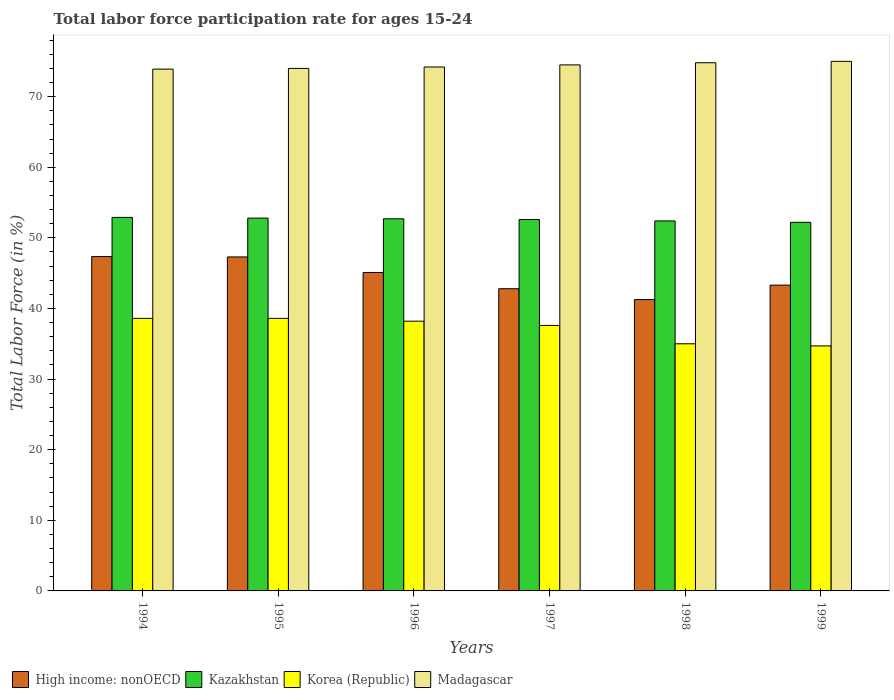How many different coloured bars are there?
Offer a very short reply. 4. How many bars are there on the 1st tick from the left?
Offer a very short reply. 4. How many bars are there on the 2nd tick from the right?
Offer a terse response. 4. What is the label of the 4th group of bars from the left?
Your answer should be compact. 1997. What is the labor force participation rate in Kazakhstan in 1996?
Ensure brevity in your answer.  52.7. Across all years, what is the maximum labor force participation rate in Kazakhstan?
Keep it short and to the point. 52.9. Across all years, what is the minimum labor force participation rate in Kazakhstan?
Your response must be concise. 52.2. In which year was the labor force participation rate in Kazakhstan maximum?
Give a very brief answer. 1994. In which year was the labor force participation rate in Korea (Republic) minimum?
Your response must be concise. 1999. What is the total labor force participation rate in Korea (Republic) in the graph?
Make the answer very short. 222.7. What is the difference between the labor force participation rate in Kazakhstan in 1995 and that in 1997?
Your answer should be compact. 0.2. What is the difference between the labor force participation rate in Korea (Republic) in 1999 and the labor force participation rate in Kazakhstan in 1995?
Ensure brevity in your answer.  -18.1. What is the average labor force participation rate in Korea (Republic) per year?
Offer a very short reply. 37.12. In the year 1999, what is the difference between the labor force participation rate in High income: nonOECD and labor force participation rate in Kazakhstan?
Give a very brief answer. -8.89. In how many years, is the labor force participation rate in Madagascar greater than 40 %?
Make the answer very short. 6. What is the ratio of the labor force participation rate in Madagascar in 1996 to that in 1997?
Your response must be concise. 1. Is the labor force participation rate in High income: nonOECD in 1994 less than that in 1996?
Your answer should be compact. No. Is the difference between the labor force participation rate in High income: nonOECD in 1996 and 1999 greater than the difference between the labor force participation rate in Kazakhstan in 1996 and 1999?
Your response must be concise. Yes. What is the difference between the highest and the second highest labor force participation rate in Madagascar?
Your answer should be very brief. 0.2. What is the difference between the highest and the lowest labor force participation rate in High income: nonOECD?
Keep it short and to the point. 6.09. In how many years, is the labor force participation rate in High income: nonOECD greater than the average labor force participation rate in High income: nonOECD taken over all years?
Make the answer very short. 3. Is the sum of the labor force participation rate in Korea (Republic) in 1995 and 1996 greater than the maximum labor force participation rate in High income: nonOECD across all years?
Provide a succinct answer. Yes. Is it the case that in every year, the sum of the labor force participation rate in High income: nonOECD and labor force participation rate in Madagascar is greater than the sum of labor force participation rate in Kazakhstan and labor force participation rate in Korea (Republic)?
Provide a succinct answer. Yes. What does the 2nd bar from the left in 1998 represents?
Provide a short and direct response. Kazakhstan. What does the 1st bar from the right in 1999 represents?
Keep it short and to the point. Madagascar. Are all the bars in the graph horizontal?
Make the answer very short. No. How many years are there in the graph?
Your response must be concise. 6. What is the difference between two consecutive major ticks on the Y-axis?
Ensure brevity in your answer.  10. Does the graph contain any zero values?
Make the answer very short. No. How many legend labels are there?
Provide a succinct answer. 4. How are the legend labels stacked?
Offer a terse response. Horizontal. What is the title of the graph?
Offer a terse response. Total labor force participation rate for ages 15-24. Does "South Asia" appear as one of the legend labels in the graph?
Your response must be concise. No. What is the Total Labor Force (in %) in High income: nonOECD in 1994?
Keep it short and to the point. 47.35. What is the Total Labor Force (in %) of Kazakhstan in 1994?
Keep it short and to the point. 52.9. What is the Total Labor Force (in %) in Korea (Republic) in 1994?
Your answer should be compact. 38.6. What is the Total Labor Force (in %) in Madagascar in 1994?
Ensure brevity in your answer.  73.9. What is the Total Labor Force (in %) of High income: nonOECD in 1995?
Your answer should be very brief. 47.3. What is the Total Labor Force (in %) in Kazakhstan in 1995?
Your answer should be very brief. 52.8. What is the Total Labor Force (in %) in Korea (Republic) in 1995?
Ensure brevity in your answer.  38.6. What is the Total Labor Force (in %) in High income: nonOECD in 1996?
Your answer should be compact. 45.1. What is the Total Labor Force (in %) of Kazakhstan in 1996?
Give a very brief answer. 52.7. What is the Total Labor Force (in %) of Korea (Republic) in 1996?
Offer a terse response. 38.2. What is the Total Labor Force (in %) in Madagascar in 1996?
Ensure brevity in your answer.  74.2. What is the Total Labor Force (in %) of High income: nonOECD in 1997?
Your answer should be compact. 42.8. What is the Total Labor Force (in %) of Kazakhstan in 1997?
Offer a very short reply. 52.6. What is the Total Labor Force (in %) in Korea (Republic) in 1997?
Make the answer very short. 37.6. What is the Total Labor Force (in %) of Madagascar in 1997?
Keep it short and to the point. 74.5. What is the Total Labor Force (in %) of High income: nonOECD in 1998?
Keep it short and to the point. 41.26. What is the Total Labor Force (in %) of Kazakhstan in 1998?
Give a very brief answer. 52.4. What is the Total Labor Force (in %) in Madagascar in 1998?
Your answer should be very brief. 74.8. What is the Total Labor Force (in %) in High income: nonOECD in 1999?
Your answer should be compact. 43.31. What is the Total Labor Force (in %) in Kazakhstan in 1999?
Give a very brief answer. 52.2. What is the Total Labor Force (in %) in Korea (Republic) in 1999?
Keep it short and to the point. 34.7. Across all years, what is the maximum Total Labor Force (in %) in High income: nonOECD?
Provide a succinct answer. 47.35. Across all years, what is the maximum Total Labor Force (in %) of Kazakhstan?
Your answer should be compact. 52.9. Across all years, what is the maximum Total Labor Force (in %) of Korea (Republic)?
Ensure brevity in your answer.  38.6. Across all years, what is the maximum Total Labor Force (in %) in Madagascar?
Offer a terse response. 75. Across all years, what is the minimum Total Labor Force (in %) of High income: nonOECD?
Provide a succinct answer. 41.26. Across all years, what is the minimum Total Labor Force (in %) in Kazakhstan?
Offer a terse response. 52.2. Across all years, what is the minimum Total Labor Force (in %) of Korea (Republic)?
Your answer should be compact. 34.7. Across all years, what is the minimum Total Labor Force (in %) in Madagascar?
Offer a very short reply. 73.9. What is the total Total Labor Force (in %) of High income: nonOECD in the graph?
Your response must be concise. 267.12. What is the total Total Labor Force (in %) in Kazakhstan in the graph?
Your answer should be very brief. 315.6. What is the total Total Labor Force (in %) of Korea (Republic) in the graph?
Offer a terse response. 222.7. What is the total Total Labor Force (in %) in Madagascar in the graph?
Keep it short and to the point. 446.4. What is the difference between the Total Labor Force (in %) of High income: nonOECD in 1994 and that in 1995?
Offer a very short reply. 0.05. What is the difference between the Total Labor Force (in %) in Korea (Republic) in 1994 and that in 1995?
Provide a succinct answer. 0. What is the difference between the Total Labor Force (in %) of High income: nonOECD in 1994 and that in 1996?
Your answer should be compact. 2.25. What is the difference between the Total Labor Force (in %) of Kazakhstan in 1994 and that in 1996?
Provide a succinct answer. 0.2. What is the difference between the Total Labor Force (in %) of High income: nonOECD in 1994 and that in 1997?
Make the answer very short. 4.55. What is the difference between the Total Labor Force (in %) in Kazakhstan in 1994 and that in 1997?
Offer a very short reply. 0.3. What is the difference between the Total Labor Force (in %) in Korea (Republic) in 1994 and that in 1997?
Provide a short and direct response. 1. What is the difference between the Total Labor Force (in %) of Madagascar in 1994 and that in 1997?
Provide a succinct answer. -0.6. What is the difference between the Total Labor Force (in %) of High income: nonOECD in 1994 and that in 1998?
Make the answer very short. 6.09. What is the difference between the Total Labor Force (in %) in Madagascar in 1994 and that in 1998?
Give a very brief answer. -0.9. What is the difference between the Total Labor Force (in %) of High income: nonOECD in 1994 and that in 1999?
Your response must be concise. 4.04. What is the difference between the Total Labor Force (in %) of Korea (Republic) in 1994 and that in 1999?
Your response must be concise. 3.9. What is the difference between the Total Labor Force (in %) of High income: nonOECD in 1995 and that in 1996?
Provide a short and direct response. 2.2. What is the difference between the Total Labor Force (in %) of Kazakhstan in 1995 and that in 1996?
Offer a terse response. 0.1. What is the difference between the Total Labor Force (in %) in Korea (Republic) in 1995 and that in 1996?
Make the answer very short. 0.4. What is the difference between the Total Labor Force (in %) of Madagascar in 1995 and that in 1996?
Provide a short and direct response. -0.2. What is the difference between the Total Labor Force (in %) of High income: nonOECD in 1995 and that in 1997?
Your answer should be compact. 4.5. What is the difference between the Total Labor Force (in %) of Korea (Republic) in 1995 and that in 1997?
Provide a succinct answer. 1. What is the difference between the Total Labor Force (in %) in Madagascar in 1995 and that in 1997?
Your answer should be compact. -0.5. What is the difference between the Total Labor Force (in %) of High income: nonOECD in 1995 and that in 1998?
Your answer should be very brief. 6.04. What is the difference between the Total Labor Force (in %) in Kazakhstan in 1995 and that in 1998?
Keep it short and to the point. 0.4. What is the difference between the Total Labor Force (in %) in Korea (Republic) in 1995 and that in 1998?
Ensure brevity in your answer.  3.6. What is the difference between the Total Labor Force (in %) in Madagascar in 1995 and that in 1998?
Provide a succinct answer. -0.8. What is the difference between the Total Labor Force (in %) of High income: nonOECD in 1995 and that in 1999?
Make the answer very short. 3.99. What is the difference between the Total Labor Force (in %) in Kazakhstan in 1995 and that in 1999?
Offer a terse response. 0.6. What is the difference between the Total Labor Force (in %) of High income: nonOECD in 1996 and that in 1997?
Offer a very short reply. 2.3. What is the difference between the Total Labor Force (in %) in Madagascar in 1996 and that in 1997?
Give a very brief answer. -0.3. What is the difference between the Total Labor Force (in %) in High income: nonOECD in 1996 and that in 1998?
Provide a short and direct response. 3.84. What is the difference between the Total Labor Force (in %) of Korea (Republic) in 1996 and that in 1998?
Ensure brevity in your answer.  3.2. What is the difference between the Total Labor Force (in %) of High income: nonOECD in 1996 and that in 1999?
Keep it short and to the point. 1.79. What is the difference between the Total Labor Force (in %) in Kazakhstan in 1996 and that in 1999?
Your response must be concise. 0.5. What is the difference between the Total Labor Force (in %) of Korea (Republic) in 1996 and that in 1999?
Offer a very short reply. 3.5. What is the difference between the Total Labor Force (in %) in Madagascar in 1996 and that in 1999?
Your answer should be compact. -0.8. What is the difference between the Total Labor Force (in %) of High income: nonOECD in 1997 and that in 1998?
Your answer should be compact. 1.54. What is the difference between the Total Labor Force (in %) of Kazakhstan in 1997 and that in 1998?
Provide a succinct answer. 0.2. What is the difference between the Total Labor Force (in %) of Madagascar in 1997 and that in 1998?
Ensure brevity in your answer.  -0.3. What is the difference between the Total Labor Force (in %) in High income: nonOECD in 1997 and that in 1999?
Offer a terse response. -0.51. What is the difference between the Total Labor Force (in %) of Kazakhstan in 1997 and that in 1999?
Give a very brief answer. 0.4. What is the difference between the Total Labor Force (in %) in Madagascar in 1997 and that in 1999?
Offer a very short reply. -0.5. What is the difference between the Total Labor Force (in %) of High income: nonOECD in 1998 and that in 1999?
Keep it short and to the point. -2.05. What is the difference between the Total Labor Force (in %) in Madagascar in 1998 and that in 1999?
Give a very brief answer. -0.2. What is the difference between the Total Labor Force (in %) in High income: nonOECD in 1994 and the Total Labor Force (in %) in Kazakhstan in 1995?
Your answer should be compact. -5.45. What is the difference between the Total Labor Force (in %) in High income: nonOECD in 1994 and the Total Labor Force (in %) in Korea (Republic) in 1995?
Provide a short and direct response. 8.75. What is the difference between the Total Labor Force (in %) of High income: nonOECD in 1994 and the Total Labor Force (in %) of Madagascar in 1995?
Your response must be concise. -26.65. What is the difference between the Total Labor Force (in %) in Kazakhstan in 1994 and the Total Labor Force (in %) in Korea (Republic) in 1995?
Your response must be concise. 14.3. What is the difference between the Total Labor Force (in %) in Kazakhstan in 1994 and the Total Labor Force (in %) in Madagascar in 1995?
Give a very brief answer. -21.1. What is the difference between the Total Labor Force (in %) in Korea (Republic) in 1994 and the Total Labor Force (in %) in Madagascar in 1995?
Offer a very short reply. -35.4. What is the difference between the Total Labor Force (in %) in High income: nonOECD in 1994 and the Total Labor Force (in %) in Kazakhstan in 1996?
Your response must be concise. -5.35. What is the difference between the Total Labor Force (in %) in High income: nonOECD in 1994 and the Total Labor Force (in %) in Korea (Republic) in 1996?
Provide a succinct answer. 9.15. What is the difference between the Total Labor Force (in %) in High income: nonOECD in 1994 and the Total Labor Force (in %) in Madagascar in 1996?
Offer a very short reply. -26.85. What is the difference between the Total Labor Force (in %) in Kazakhstan in 1994 and the Total Labor Force (in %) in Madagascar in 1996?
Your response must be concise. -21.3. What is the difference between the Total Labor Force (in %) of Korea (Republic) in 1994 and the Total Labor Force (in %) of Madagascar in 1996?
Provide a succinct answer. -35.6. What is the difference between the Total Labor Force (in %) of High income: nonOECD in 1994 and the Total Labor Force (in %) of Kazakhstan in 1997?
Keep it short and to the point. -5.25. What is the difference between the Total Labor Force (in %) in High income: nonOECD in 1994 and the Total Labor Force (in %) in Korea (Republic) in 1997?
Keep it short and to the point. 9.75. What is the difference between the Total Labor Force (in %) in High income: nonOECD in 1994 and the Total Labor Force (in %) in Madagascar in 1997?
Your answer should be compact. -27.15. What is the difference between the Total Labor Force (in %) of Kazakhstan in 1994 and the Total Labor Force (in %) of Madagascar in 1997?
Offer a very short reply. -21.6. What is the difference between the Total Labor Force (in %) in Korea (Republic) in 1994 and the Total Labor Force (in %) in Madagascar in 1997?
Your answer should be compact. -35.9. What is the difference between the Total Labor Force (in %) in High income: nonOECD in 1994 and the Total Labor Force (in %) in Kazakhstan in 1998?
Your answer should be very brief. -5.05. What is the difference between the Total Labor Force (in %) of High income: nonOECD in 1994 and the Total Labor Force (in %) of Korea (Republic) in 1998?
Provide a succinct answer. 12.35. What is the difference between the Total Labor Force (in %) of High income: nonOECD in 1994 and the Total Labor Force (in %) of Madagascar in 1998?
Keep it short and to the point. -27.45. What is the difference between the Total Labor Force (in %) in Kazakhstan in 1994 and the Total Labor Force (in %) in Madagascar in 1998?
Provide a short and direct response. -21.9. What is the difference between the Total Labor Force (in %) of Korea (Republic) in 1994 and the Total Labor Force (in %) of Madagascar in 1998?
Your answer should be compact. -36.2. What is the difference between the Total Labor Force (in %) of High income: nonOECD in 1994 and the Total Labor Force (in %) of Kazakhstan in 1999?
Provide a short and direct response. -4.85. What is the difference between the Total Labor Force (in %) in High income: nonOECD in 1994 and the Total Labor Force (in %) in Korea (Republic) in 1999?
Offer a terse response. 12.65. What is the difference between the Total Labor Force (in %) in High income: nonOECD in 1994 and the Total Labor Force (in %) in Madagascar in 1999?
Ensure brevity in your answer.  -27.65. What is the difference between the Total Labor Force (in %) of Kazakhstan in 1994 and the Total Labor Force (in %) of Madagascar in 1999?
Give a very brief answer. -22.1. What is the difference between the Total Labor Force (in %) in Korea (Republic) in 1994 and the Total Labor Force (in %) in Madagascar in 1999?
Offer a very short reply. -36.4. What is the difference between the Total Labor Force (in %) in High income: nonOECD in 1995 and the Total Labor Force (in %) in Kazakhstan in 1996?
Make the answer very short. -5.4. What is the difference between the Total Labor Force (in %) in High income: nonOECD in 1995 and the Total Labor Force (in %) in Korea (Republic) in 1996?
Your answer should be very brief. 9.1. What is the difference between the Total Labor Force (in %) in High income: nonOECD in 1995 and the Total Labor Force (in %) in Madagascar in 1996?
Make the answer very short. -26.9. What is the difference between the Total Labor Force (in %) of Kazakhstan in 1995 and the Total Labor Force (in %) of Madagascar in 1996?
Your answer should be compact. -21.4. What is the difference between the Total Labor Force (in %) in Korea (Republic) in 1995 and the Total Labor Force (in %) in Madagascar in 1996?
Your answer should be compact. -35.6. What is the difference between the Total Labor Force (in %) of High income: nonOECD in 1995 and the Total Labor Force (in %) of Kazakhstan in 1997?
Keep it short and to the point. -5.3. What is the difference between the Total Labor Force (in %) in High income: nonOECD in 1995 and the Total Labor Force (in %) in Korea (Republic) in 1997?
Keep it short and to the point. 9.7. What is the difference between the Total Labor Force (in %) of High income: nonOECD in 1995 and the Total Labor Force (in %) of Madagascar in 1997?
Make the answer very short. -27.2. What is the difference between the Total Labor Force (in %) of Kazakhstan in 1995 and the Total Labor Force (in %) of Korea (Republic) in 1997?
Your response must be concise. 15.2. What is the difference between the Total Labor Force (in %) of Kazakhstan in 1995 and the Total Labor Force (in %) of Madagascar in 1997?
Your response must be concise. -21.7. What is the difference between the Total Labor Force (in %) in Korea (Republic) in 1995 and the Total Labor Force (in %) in Madagascar in 1997?
Make the answer very short. -35.9. What is the difference between the Total Labor Force (in %) of High income: nonOECD in 1995 and the Total Labor Force (in %) of Kazakhstan in 1998?
Your response must be concise. -5.1. What is the difference between the Total Labor Force (in %) of High income: nonOECD in 1995 and the Total Labor Force (in %) of Korea (Republic) in 1998?
Your answer should be compact. 12.3. What is the difference between the Total Labor Force (in %) in High income: nonOECD in 1995 and the Total Labor Force (in %) in Madagascar in 1998?
Provide a succinct answer. -27.5. What is the difference between the Total Labor Force (in %) in Kazakhstan in 1995 and the Total Labor Force (in %) in Madagascar in 1998?
Make the answer very short. -22. What is the difference between the Total Labor Force (in %) in Korea (Republic) in 1995 and the Total Labor Force (in %) in Madagascar in 1998?
Your answer should be very brief. -36.2. What is the difference between the Total Labor Force (in %) in High income: nonOECD in 1995 and the Total Labor Force (in %) in Kazakhstan in 1999?
Give a very brief answer. -4.9. What is the difference between the Total Labor Force (in %) of High income: nonOECD in 1995 and the Total Labor Force (in %) of Korea (Republic) in 1999?
Offer a terse response. 12.6. What is the difference between the Total Labor Force (in %) in High income: nonOECD in 1995 and the Total Labor Force (in %) in Madagascar in 1999?
Ensure brevity in your answer.  -27.7. What is the difference between the Total Labor Force (in %) in Kazakhstan in 1995 and the Total Labor Force (in %) in Madagascar in 1999?
Your answer should be very brief. -22.2. What is the difference between the Total Labor Force (in %) in Korea (Republic) in 1995 and the Total Labor Force (in %) in Madagascar in 1999?
Ensure brevity in your answer.  -36.4. What is the difference between the Total Labor Force (in %) in High income: nonOECD in 1996 and the Total Labor Force (in %) in Kazakhstan in 1997?
Provide a succinct answer. -7.5. What is the difference between the Total Labor Force (in %) in High income: nonOECD in 1996 and the Total Labor Force (in %) in Korea (Republic) in 1997?
Your answer should be compact. 7.5. What is the difference between the Total Labor Force (in %) of High income: nonOECD in 1996 and the Total Labor Force (in %) of Madagascar in 1997?
Your response must be concise. -29.4. What is the difference between the Total Labor Force (in %) in Kazakhstan in 1996 and the Total Labor Force (in %) in Madagascar in 1997?
Provide a succinct answer. -21.8. What is the difference between the Total Labor Force (in %) in Korea (Republic) in 1996 and the Total Labor Force (in %) in Madagascar in 1997?
Offer a very short reply. -36.3. What is the difference between the Total Labor Force (in %) in High income: nonOECD in 1996 and the Total Labor Force (in %) in Kazakhstan in 1998?
Your answer should be compact. -7.3. What is the difference between the Total Labor Force (in %) of High income: nonOECD in 1996 and the Total Labor Force (in %) of Korea (Republic) in 1998?
Your answer should be very brief. 10.1. What is the difference between the Total Labor Force (in %) in High income: nonOECD in 1996 and the Total Labor Force (in %) in Madagascar in 1998?
Your answer should be very brief. -29.7. What is the difference between the Total Labor Force (in %) in Kazakhstan in 1996 and the Total Labor Force (in %) in Madagascar in 1998?
Give a very brief answer. -22.1. What is the difference between the Total Labor Force (in %) of Korea (Republic) in 1996 and the Total Labor Force (in %) of Madagascar in 1998?
Give a very brief answer. -36.6. What is the difference between the Total Labor Force (in %) of High income: nonOECD in 1996 and the Total Labor Force (in %) of Kazakhstan in 1999?
Provide a succinct answer. -7.1. What is the difference between the Total Labor Force (in %) in High income: nonOECD in 1996 and the Total Labor Force (in %) in Korea (Republic) in 1999?
Offer a very short reply. 10.4. What is the difference between the Total Labor Force (in %) of High income: nonOECD in 1996 and the Total Labor Force (in %) of Madagascar in 1999?
Provide a short and direct response. -29.9. What is the difference between the Total Labor Force (in %) of Kazakhstan in 1996 and the Total Labor Force (in %) of Korea (Republic) in 1999?
Give a very brief answer. 18. What is the difference between the Total Labor Force (in %) in Kazakhstan in 1996 and the Total Labor Force (in %) in Madagascar in 1999?
Provide a succinct answer. -22.3. What is the difference between the Total Labor Force (in %) of Korea (Republic) in 1996 and the Total Labor Force (in %) of Madagascar in 1999?
Your answer should be very brief. -36.8. What is the difference between the Total Labor Force (in %) in High income: nonOECD in 1997 and the Total Labor Force (in %) in Kazakhstan in 1998?
Offer a terse response. -9.6. What is the difference between the Total Labor Force (in %) of High income: nonOECD in 1997 and the Total Labor Force (in %) of Korea (Republic) in 1998?
Provide a short and direct response. 7.8. What is the difference between the Total Labor Force (in %) of High income: nonOECD in 1997 and the Total Labor Force (in %) of Madagascar in 1998?
Your answer should be compact. -32. What is the difference between the Total Labor Force (in %) in Kazakhstan in 1997 and the Total Labor Force (in %) in Madagascar in 1998?
Offer a very short reply. -22.2. What is the difference between the Total Labor Force (in %) in Korea (Republic) in 1997 and the Total Labor Force (in %) in Madagascar in 1998?
Your answer should be compact. -37.2. What is the difference between the Total Labor Force (in %) in High income: nonOECD in 1997 and the Total Labor Force (in %) in Kazakhstan in 1999?
Offer a very short reply. -9.4. What is the difference between the Total Labor Force (in %) in High income: nonOECD in 1997 and the Total Labor Force (in %) in Korea (Republic) in 1999?
Your answer should be compact. 8.1. What is the difference between the Total Labor Force (in %) of High income: nonOECD in 1997 and the Total Labor Force (in %) of Madagascar in 1999?
Your response must be concise. -32.2. What is the difference between the Total Labor Force (in %) of Kazakhstan in 1997 and the Total Labor Force (in %) of Madagascar in 1999?
Provide a succinct answer. -22.4. What is the difference between the Total Labor Force (in %) of Korea (Republic) in 1997 and the Total Labor Force (in %) of Madagascar in 1999?
Keep it short and to the point. -37.4. What is the difference between the Total Labor Force (in %) of High income: nonOECD in 1998 and the Total Labor Force (in %) of Kazakhstan in 1999?
Provide a short and direct response. -10.94. What is the difference between the Total Labor Force (in %) in High income: nonOECD in 1998 and the Total Labor Force (in %) in Korea (Republic) in 1999?
Provide a short and direct response. 6.56. What is the difference between the Total Labor Force (in %) of High income: nonOECD in 1998 and the Total Labor Force (in %) of Madagascar in 1999?
Your answer should be compact. -33.74. What is the difference between the Total Labor Force (in %) of Kazakhstan in 1998 and the Total Labor Force (in %) of Korea (Republic) in 1999?
Ensure brevity in your answer.  17.7. What is the difference between the Total Labor Force (in %) in Kazakhstan in 1998 and the Total Labor Force (in %) in Madagascar in 1999?
Provide a short and direct response. -22.6. What is the average Total Labor Force (in %) of High income: nonOECD per year?
Your answer should be very brief. 44.52. What is the average Total Labor Force (in %) of Kazakhstan per year?
Provide a succinct answer. 52.6. What is the average Total Labor Force (in %) of Korea (Republic) per year?
Keep it short and to the point. 37.12. What is the average Total Labor Force (in %) of Madagascar per year?
Keep it short and to the point. 74.4. In the year 1994, what is the difference between the Total Labor Force (in %) in High income: nonOECD and Total Labor Force (in %) in Kazakhstan?
Make the answer very short. -5.55. In the year 1994, what is the difference between the Total Labor Force (in %) in High income: nonOECD and Total Labor Force (in %) in Korea (Republic)?
Your response must be concise. 8.75. In the year 1994, what is the difference between the Total Labor Force (in %) in High income: nonOECD and Total Labor Force (in %) in Madagascar?
Offer a terse response. -26.55. In the year 1994, what is the difference between the Total Labor Force (in %) of Korea (Republic) and Total Labor Force (in %) of Madagascar?
Provide a succinct answer. -35.3. In the year 1995, what is the difference between the Total Labor Force (in %) in High income: nonOECD and Total Labor Force (in %) in Kazakhstan?
Provide a succinct answer. -5.5. In the year 1995, what is the difference between the Total Labor Force (in %) in High income: nonOECD and Total Labor Force (in %) in Korea (Republic)?
Your response must be concise. 8.7. In the year 1995, what is the difference between the Total Labor Force (in %) in High income: nonOECD and Total Labor Force (in %) in Madagascar?
Offer a very short reply. -26.7. In the year 1995, what is the difference between the Total Labor Force (in %) in Kazakhstan and Total Labor Force (in %) in Korea (Republic)?
Give a very brief answer. 14.2. In the year 1995, what is the difference between the Total Labor Force (in %) in Kazakhstan and Total Labor Force (in %) in Madagascar?
Your response must be concise. -21.2. In the year 1995, what is the difference between the Total Labor Force (in %) of Korea (Republic) and Total Labor Force (in %) of Madagascar?
Ensure brevity in your answer.  -35.4. In the year 1996, what is the difference between the Total Labor Force (in %) in High income: nonOECD and Total Labor Force (in %) in Kazakhstan?
Give a very brief answer. -7.6. In the year 1996, what is the difference between the Total Labor Force (in %) of High income: nonOECD and Total Labor Force (in %) of Korea (Republic)?
Your answer should be compact. 6.9. In the year 1996, what is the difference between the Total Labor Force (in %) of High income: nonOECD and Total Labor Force (in %) of Madagascar?
Provide a succinct answer. -29.1. In the year 1996, what is the difference between the Total Labor Force (in %) of Kazakhstan and Total Labor Force (in %) of Korea (Republic)?
Keep it short and to the point. 14.5. In the year 1996, what is the difference between the Total Labor Force (in %) of Kazakhstan and Total Labor Force (in %) of Madagascar?
Keep it short and to the point. -21.5. In the year 1996, what is the difference between the Total Labor Force (in %) in Korea (Republic) and Total Labor Force (in %) in Madagascar?
Provide a succinct answer. -36. In the year 1997, what is the difference between the Total Labor Force (in %) in High income: nonOECD and Total Labor Force (in %) in Kazakhstan?
Your response must be concise. -9.8. In the year 1997, what is the difference between the Total Labor Force (in %) in High income: nonOECD and Total Labor Force (in %) in Korea (Republic)?
Keep it short and to the point. 5.2. In the year 1997, what is the difference between the Total Labor Force (in %) in High income: nonOECD and Total Labor Force (in %) in Madagascar?
Your answer should be compact. -31.7. In the year 1997, what is the difference between the Total Labor Force (in %) in Kazakhstan and Total Labor Force (in %) in Madagascar?
Provide a short and direct response. -21.9. In the year 1997, what is the difference between the Total Labor Force (in %) in Korea (Republic) and Total Labor Force (in %) in Madagascar?
Offer a terse response. -36.9. In the year 1998, what is the difference between the Total Labor Force (in %) of High income: nonOECD and Total Labor Force (in %) of Kazakhstan?
Offer a terse response. -11.14. In the year 1998, what is the difference between the Total Labor Force (in %) in High income: nonOECD and Total Labor Force (in %) in Korea (Republic)?
Ensure brevity in your answer.  6.26. In the year 1998, what is the difference between the Total Labor Force (in %) of High income: nonOECD and Total Labor Force (in %) of Madagascar?
Provide a short and direct response. -33.54. In the year 1998, what is the difference between the Total Labor Force (in %) in Kazakhstan and Total Labor Force (in %) in Madagascar?
Your response must be concise. -22.4. In the year 1998, what is the difference between the Total Labor Force (in %) of Korea (Republic) and Total Labor Force (in %) of Madagascar?
Make the answer very short. -39.8. In the year 1999, what is the difference between the Total Labor Force (in %) of High income: nonOECD and Total Labor Force (in %) of Kazakhstan?
Your answer should be very brief. -8.89. In the year 1999, what is the difference between the Total Labor Force (in %) in High income: nonOECD and Total Labor Force (in %) in Korea (Republic)?
Your answer should be very brief. 8.61. In the year 1999, what is the difference between the Total Labor Force (in %) in High income: nonOECD and Total Labor Force (in %) in Madagascar?
Provide a succinct answer. -31.69. In the year 1999, what is the difference between the Total Labor Force (in %) of Kazakhstan and Total Labor Force (in %) of Madagascar?
Your answer should be very brief. -22.8. In the year 1999, what is the difference between the Total Labor Force (in %) of Korea (Republic) and Total Labor Force (in %) of Madagascar?
Give a very brief answer. -40.3. What is the ratio of the Total Labor Force (in %) of Madagascar in 1994 to that in 1995?
Provide a short and direct response. 1. What is the ratio of the Total Labor Force (in %) of High income: nonOECD in 1994 to that in 1996?
Provide a short and direct response. 1.05. What is the ratio of the Total Labor Force (in %) in Korea (Republic) in 1994 to that in 1996?
Provide a succinct answer. 1.01. What is the ratio of the Total Labor Force (in %) in High income: nonOECD in 1994 to that in 1997?
Keep it short and to the point. 1.11. What is the ratio of the Total Labor Force (in %) of Korea (Republic) in 1994 to that in 1997?
Ensure brevity in your answer.  1.03. What is the ratio of the Total Labor Force (in %) of High income: nonOECD in 1994 to that in 1998?
Your answer should be very brief. 1.15. What is the ratio of the Total Labor Force (in %) of Kazakhstan in 1994 to that in 1998?
Your answer should be compact. 1.01. What is the ratio of the Total Labor Force (in %) in Korea (Republic) in 1994 to that in 1998?
Ensure brevity in your answer.  1.1. What is the ratio of the Total Labor Force (in %) in High income: nonOECD in 1994 to that in 1999?
Give a very brief answer. 1.09. What is the ratio of the Total Labor Force (in %) of Kazakhstan in 1994 to that in 1999?
Give a very brief answer. 1.01. What is the ratio of the Total Labor Force (in %) of Korea (Republic) in 1994 to that in 1999?
Ensure brevity in your answer.  1.11. What is the ratio of the Total Labor Force (in %) of High income: nonOECD in 1995 to that in 1996?
Your answer should be very brief. 1.05. What is the ratio of the Total Labor Force (in %) in Kazakhstan in 1995 to that in 1996?
Offer a very short reply. 1. What is the ratio of the Total Labor Force (in %) of Korea (Republic) in 1995 to that in 1996?
Make the answer very short. 1.01. What is the ratio of the Total Labor Force (in %) of High income: nonOECD in 1995 to that in 1997?
Your response must be concise. 1.11. What is the ratio of the Total Labor Force (in %) in Kazakhstan in 1995 to that in 1997?
Offer a terse response. 1. What is the ratio of the Total Labor Force (in %) of Korea (Republic) in 1995 to that in 1997?
Ensure brevity in your answer.  1.03. What is the ratio of the Total Labor Force (in %) in Madagascar in 1995 to that in 1997?
Your response must be concise. 0.99. What is the ratio of the Total Labor Force (in %) in High income: nonOECD in 1995 to that in 1998?
Offer a very short reply. 1.15. What is the ratio of the Total Labor Force (in %) of Kazakhstan in 1995 to that in 1998?
Your answer should be compact. 1.01. What is the ratio of the Total Labor Force (in %) in Korea (Republic) in 1995 to that in 1998?
Provide a succinct answer. 1.1. What is the ratio of the Total Labor Force (in %) in Madagascar in 1995 to that in 1998?
Your response must be concise. 0.99. What is the ratio of the Total Labor Force (in %) in High income: nonOECD in 1995 to that in 1999?
Your answer should be compact. 1.09. What is the ratio of the Total Labor Force (in %) of Kazakhstan in 1995 to that in 1999?
Offer a very short reply. 1.01. What is the ratio of the Total Labor Force (in %) of Korea (Republic) in 1995 to that in 1999?
Make the answer very short. 1.11. What is the ratio of the Total Labor Force (in %) in Madagascar in 1995 to that in 1999?
Ensure brevity in your answer.  0.99. What is the ratio of the Total Labor Force (in %) of High income: nonOECD in 1996 to that in 1997?
Your answer should be very brief. 1.05. What is the ratio of the Total Labor Force (in %) of Kazakhstan in 1996 to that in 1997?
Give a very brief answer. 1. What is the ratio of the Total Labor Force (in %) in Madagascar in 1996 to that in 1997?
Make the answer very short. 1. What is the ratio of the Total Labor Force (in %) in High income: nonOECD in 1996 to that in 1998?
Provide a short and direct response. 1.09. What is the ratio of the Total Labor Force (in %) of Kazakhstan in 1996 to that in 1998?
Your response must be concise. 1.01. What is the ratio of the Total Labor Force (in %) in Korea (Republic) in 1996 to that in 1998?
Your answer should be very brief. 1.09. What is the ratio of the Total Labor Force (in %) in High income: nonOECD in 1996 to that in 1999?
Ensure brevity in your answer.  1.04. What is the ratio of the Total Labor Force (in %) of Kazakhstan in 1996 to that in 1999?
Offer a terse response. 1.01. What is the ratio of the Total Labor Force (in %) of Korea (Republic) in 1996 to that in 1999?
Your answer should be compact. 1.1. What is the ratio of the Total Labor Force (in %) in Madagascar in 1996 to that in 1999?
Keep it short and to the point. 0.99. What is the ratio of the Total Labor Force (in %) of High income: nonOECD in 1997 to that in 1998?
Make the answer very short. 1.04. What is the ratio of the Total Labor Force (in %) of Korea (Republic) in 1997 to that in 1998?
Ensure brevity in your answer.  1.07. What is the ratio of the Total Labor Force (in %) in Madagascar in 1997 to that in 1998?
Your answer should be compact. 1. What is the ratio of the Total Labor Force (in %) in Kazakhstan in 1997 to that in 1999?
Ensure brevity in your answer.  1.01. What is the ratio of the Total Labor Force (in %) in Korea (Republic) in 1997 to that in 1999?
Your answer should be compact. 1.08. What is the ratio of the Total Labor Force (in %) in High income: nonOECD in 1998 to that in 1999?
Offer a very short reply. 0.95. What is the ratio of the Total Labor Force (in %) in Korea (Republic) in 1998 to that in 1999?
Ensure brevity in your answer.  1.01. What is the ratio of the Total Labor Force (in %) of Madagascar in 1998 to that in 1999?
Provide a short and direct response. 1. What is the difference between the highest and the second highest Total Labor Force (in %) in High income: nonOECD?
Offer a terse response. 0.05. What is the difference between the highest and the second highest Total Labor Force (in %) of Kazakhstan?
Your answer should be very brief. 0.1. What is the difference between the highest and the second highest Total Labor Force (in %) in Korea (Republic)?
Ensure brevity in your answer.  0. What is the difference between the highest and the second highest Total Labor Force (in %) of Madagascar?
Your answer should be very brief. 0.2. What is the difference between the highest and the lowest Total Labor Force (in %) in High income: nonOECD?
Your answer should be very brief. 6.09. What is the difference between the highest and the lowest Total Labor Force (in %) of Korea (Republic)?
Your answer should be compact. 3.9. What is the difference between the highest and the lowest Total Labor Force (in %) in Madagascar?
Your answer should be compact. 1.1. 